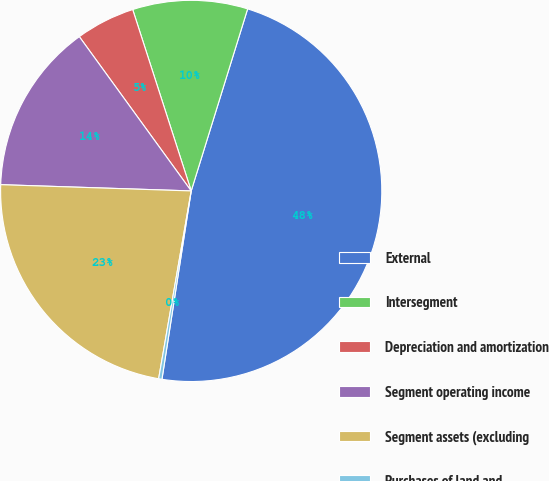<chart> <loc_0><loc_0><loc_500><loc_500><pie_chart><fcel>External<fcel>Intersegment<fcel>Depreciation and amortization<fcel>Segment operating income<fcel>Segment assets (excluding<fcel>Purchases of land and<nl><fcel>47.67%<fcel>9.75%<fcel>5.02%<fcel>14.49%<fcel>22.79%<fcel>0.28%<nl></chart> 